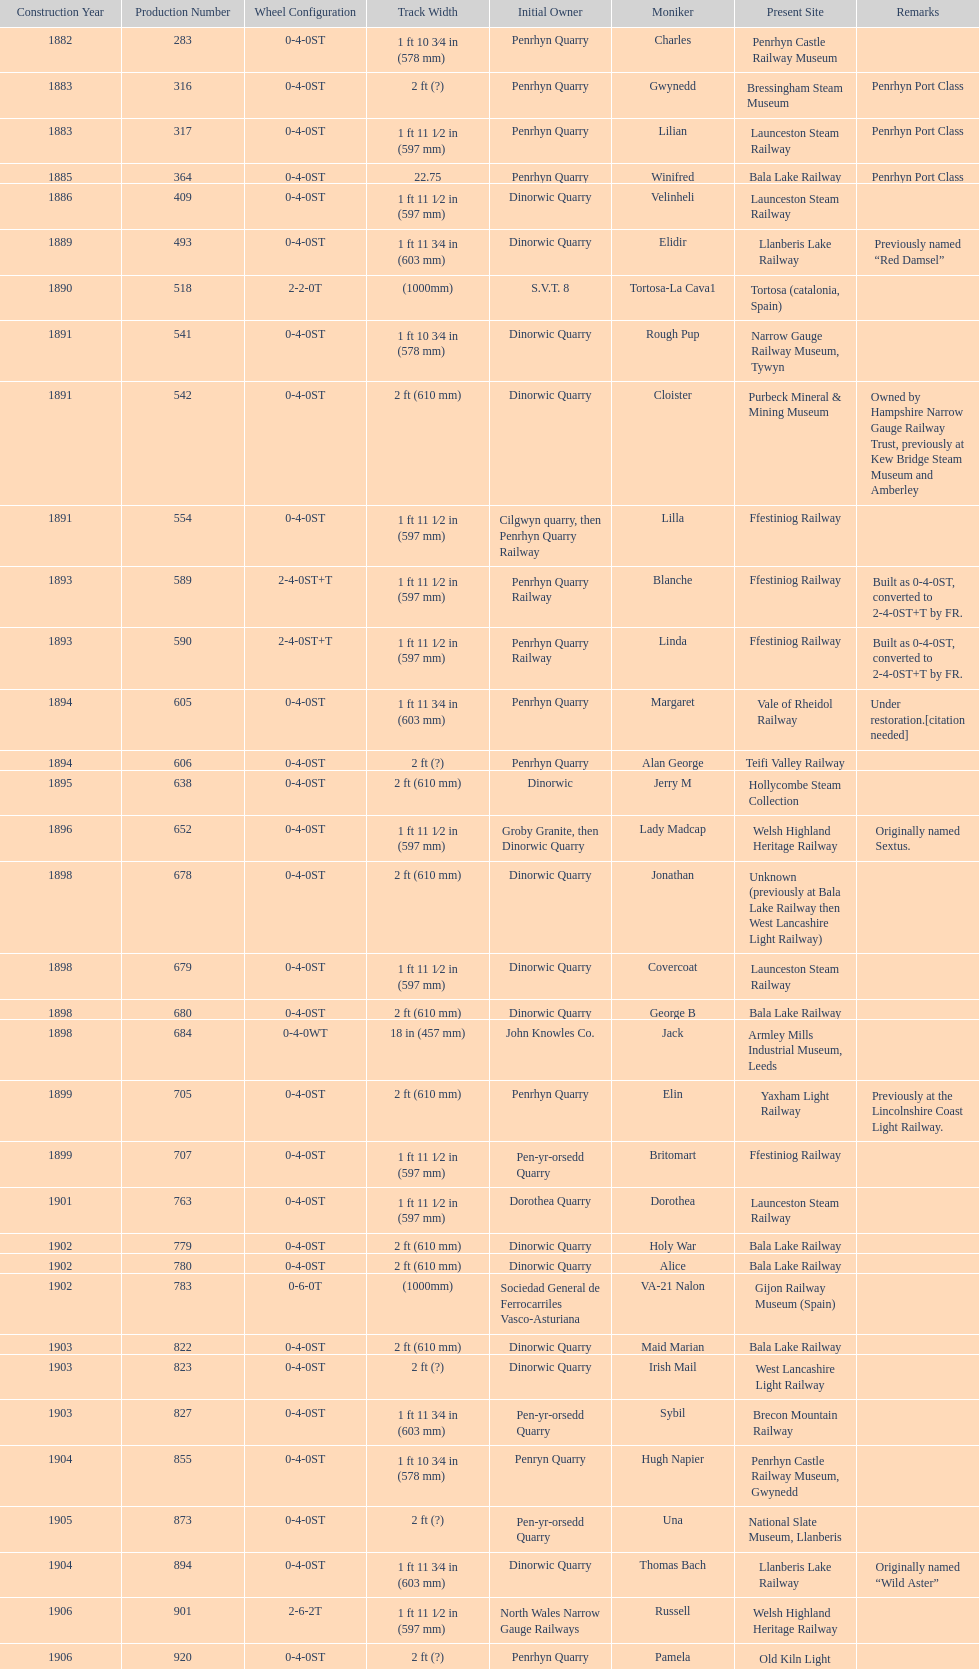In which year were the most steam locomotives built? 1898. 